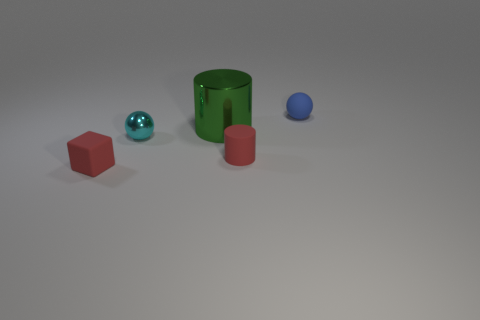How many other objects are the same color as the small matte cylinder?
Provide a succinct answer. 1. Is the number of small red cylinders left of the tiny matte cylinder greater than the number of small shiny balls that are left of the blue object?
Provide a short and direct response. No. Is there anything else that has the same size as the rubber cylinder?
Give a very brief answer. Yes. What number of spheres are either small cyan shiny things or green things?
Your response must be concise. 1. How many things are small spheres behind the cyan thing or objects?
Provide a succinct answer. 5. There is a object that is behind the cylinder that is on the left side of the red rubber object behind the red matte block; what shape is it?
Your answer should be very brief. Sphere. What number of other small objects are the same shape as the small cyan object?
Provide a short and direct response. 1. There is a tiny thing that is the same color as the tiny cylinder; what material is it?
Provide a succinct answer. Rubber. Do the green object and the small red cylinder have the same material?
Your answer should be compact. No. There is a small ball in front of the ball that is right of the tiny cyan sphere; what number of small things are on the left side of it?
Offer a terse response. 1. 